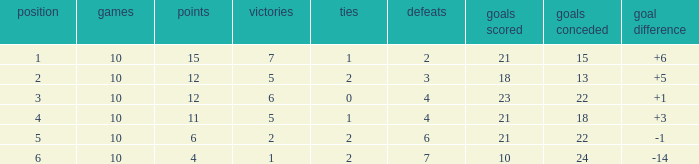Can you tell me the sum of Goals against that has the Goals for larger than 10, and the Position of 3, and the Wins smaller than 6? None. 